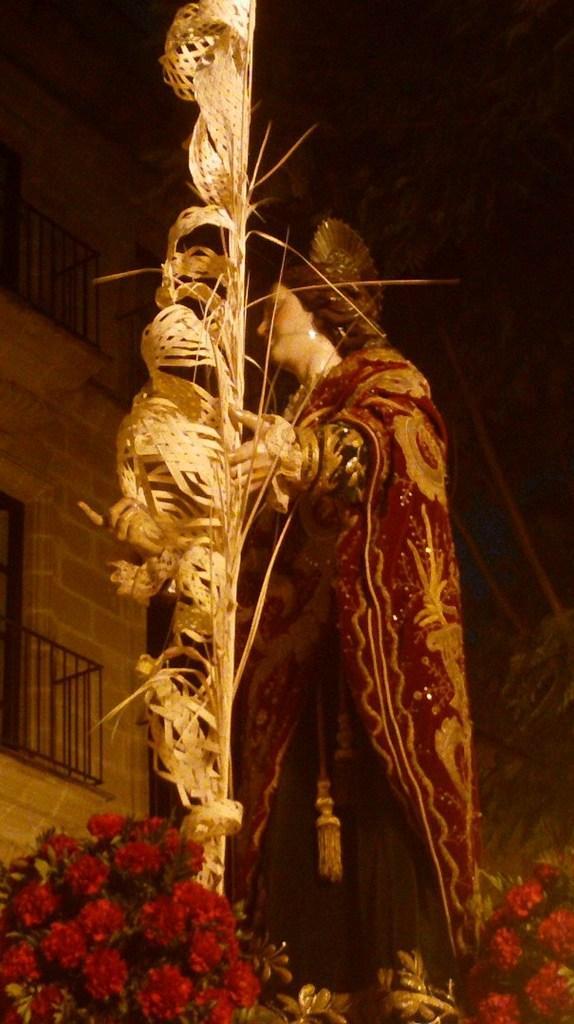Please provide a concise description of this image. In the middle of the image there is a statue of the person with red cloth on it. In the statue hand there is a decorative item. And to the left and right bottom corner of the image there are a bunch of red flowers. And to the left corner of the image there is a building with walls, balconies and doors. 